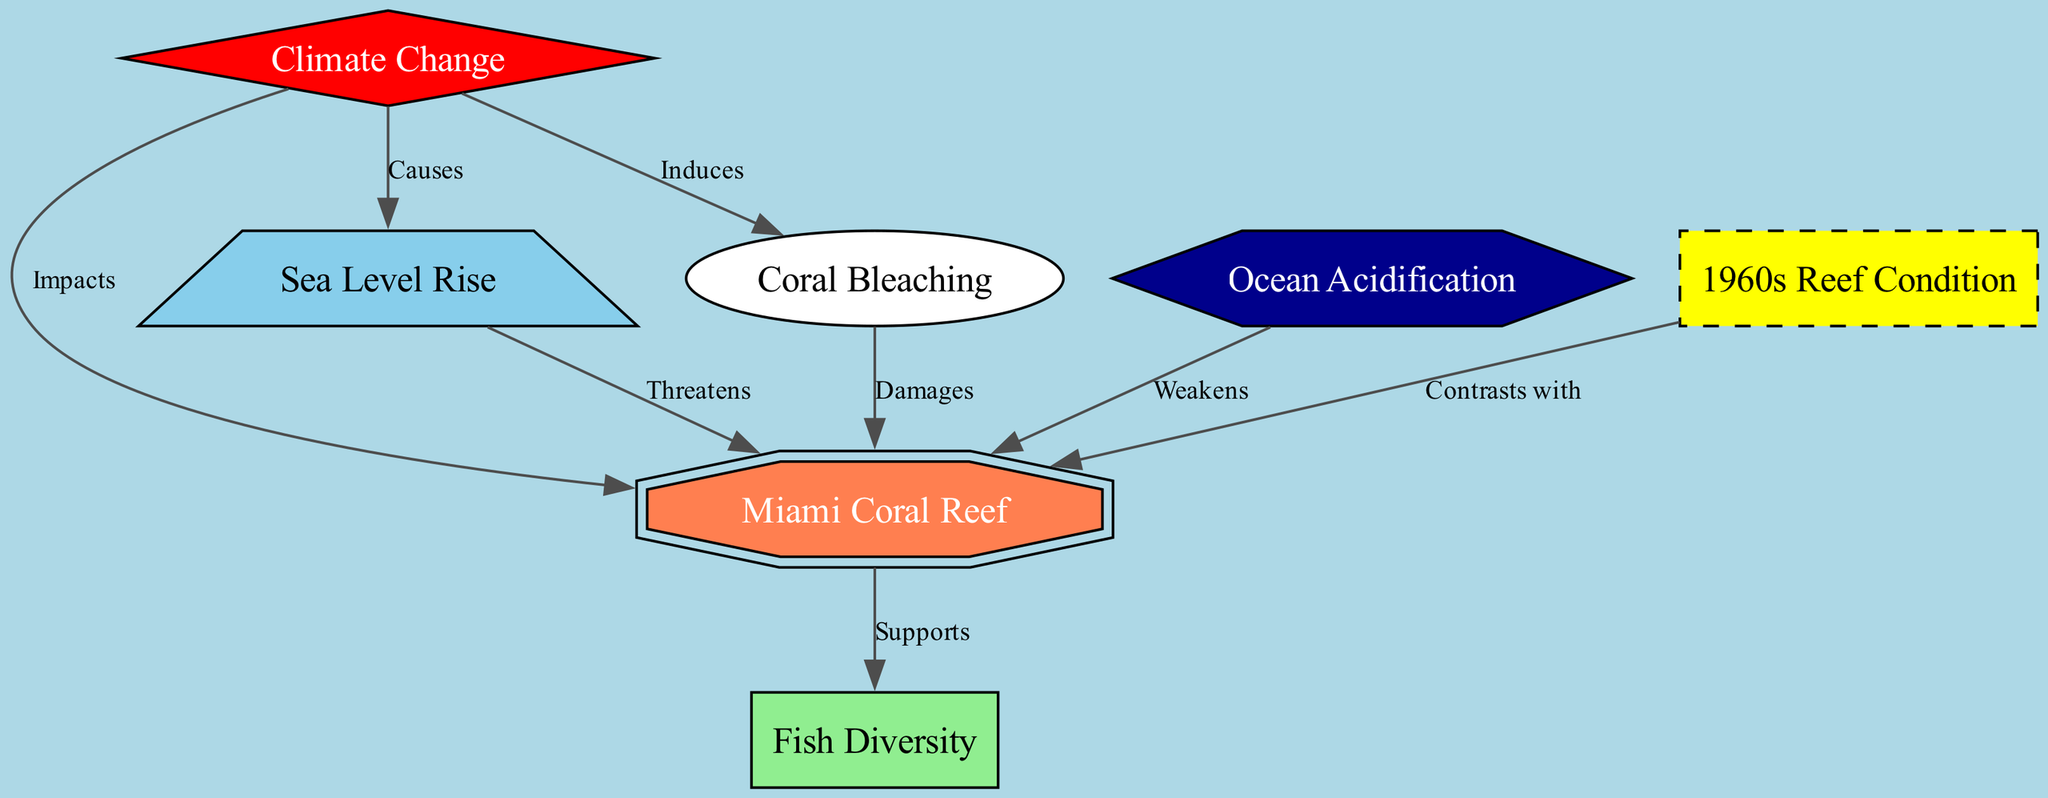What are the main threats to the Miami Coral Reef? The diagram indicates that the Miami Coral Reef is threatened by Sea Level Rise and Coral Bleaching, both of which are influenced by Climate Change. Sea Level Rise directly threatens the reef, while Coral Bleaching occurs as a result of Climate Change, which in turn damages the coral reef.
Answer: Sea Level Rise, Coral Bleaching How many nodes are present in the diagram? The diagram contains a total of 7 nodes representing various aspects of the coral reef ecosystem, including the reef itself, factors affecting it, and historical context.
Answer: 7 What does Climate Change do to the Coral Reef? According to the diagram, Climate Change has a direct impact on the Coral Reef through several pathways: it induces Coral Bleaching and is a cause of Sea Level Rise, which threatens the reef.
Answer: Impacts, Induces, Causes How does Ocean Acidification affect the Coral Reef? The diagram illustrates that Ocean Acidification weakens the Coral Reef, thereby making it more vulnerable to other threats and damages the overall health of the ecosystem.
Answer: Weakens What contrasts with the current condition of the Coral Reef? The diagram notes that the historical condition of the reef in the 1960s is presented to contrast with the current state of the Miami Coral Reef, highlighting changes that have occurred over time.
Answer: 1960s Reef Condition 